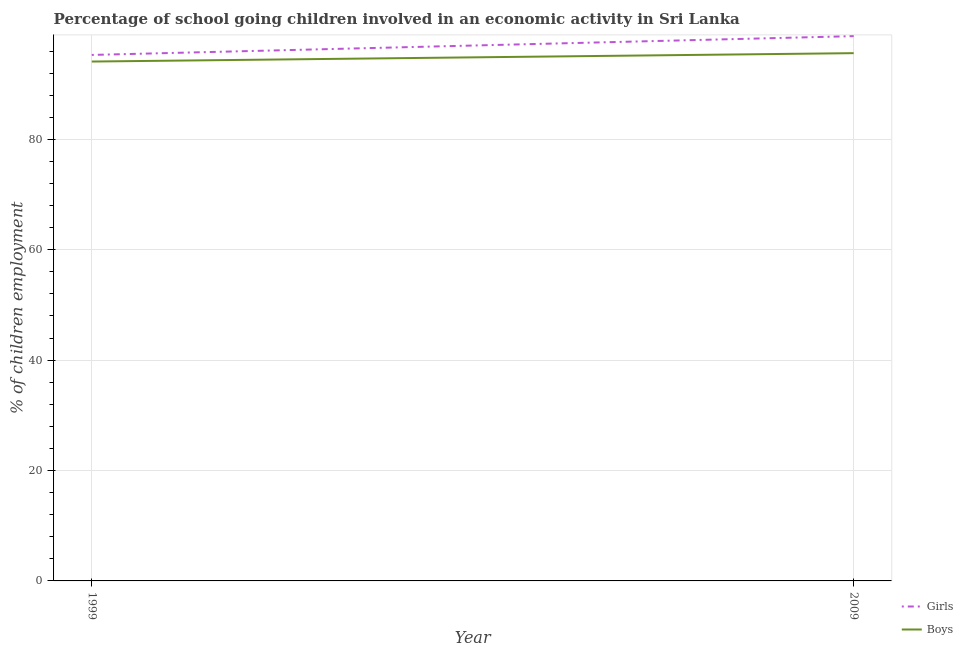Does the line corresponding to percentage of school going girls intersect with the line corresponding to percentage of school going boys?
Ensure brevity in your answer.  No. What is the percentage of school going girls in 1999?
Provide a short and direct response. 95.3. Across all years, what is the maximum percentage of school going boys?
Provide a succinct answer. 95.62. Across all years, what is the minimum percentage of school going boys?
Offer a very short reply. 94.1. In which year was the percentage of school going girls maximum?
Your answer should be very brief. 2009. In which year was the percentage of school going boys minimum?
Your answer should be very brief. 1999. What is the total percentage of school going boys in the graph?
Ensure brevity in your answer.  189.72. What is the difference between the percentage of school going girls in 1999 and that in 2009?
Give a very brief answer. -3.41. What is the difference between the percentage of school going boys in 2009 and the percentage of school going girls in 1999?
Your answer should be very brief. 0.32. What is the average percentage of school going girls per year?
Keep it short and to the point. 97. In the year 1999, what is the difference between the percentage of school going boys and percentage of school going girls?
Keep it short and to the point. -1.2. In how many years, is the percentage of school going boys greater than 52 %?
Your answer should be compact. 2. What is the ratio of the percentage of school going boys in 1999 to that in 2009?
Your response must be concise. 0.98. Does the percentage of school going girls monotonically increase over the years?
Your answer should be very brief. Yes. Is the percentage of school going boys strictly greater than the percentage of school going girls over the years?
Provide a succinct answer. No. How many lines are there?
Your response must be concise. 2. Are the values on the major ticks of Y-axis written in scientific E-notation?
Your answer should be very brief. No. Does the graph contain grids?
Your answer should be very brief. Yes. How are the legend labels stacked?
Offer a terse response. Vertical. What is the title of the graph?
Provide a succinct answer. Percentage of school going children involved in an economic activity in Sri Lanka. Does "Female" appear as one of the legend labels in the graph?
Offer a terse response. No. What is the label or title of the Y-axis?
Give a very brief answer. % of children employment. What is the % of children employment in Girls in 1999?
Your response must be concise. 95.3. What is the % of children employment in Boys in 1999?
Your response must be concise. 94.1. What is the % of children employment in Girls in 2009?
Ensure brevity in your answer.  98.71. What is the % of children employment of Boys in 2009?
Keep it short and to the point. 95.62. Across all years, what is the maximum % of children employment of Girls?
Offer a terse response. 98.71. Across all years, what is the maximum % of children employment of Boys?
Offer a very short reply. 95.62. Across all years, what is the minimum % of children employment of Girls?
Provide a short and direct response. 95.3. Across all years, what is the minimum % of children employment in Boys?
Offer a very short reply. 94.1. What is the total % of children employment of Girls in the graph?
Offer a terse response. 194. What is the total % of children employment of Boys in the graph?
Offer a very short reply. 189.72. What is the difference between the % of children employment of Girls in 1999 and that in 2009?
Offer a very short reply. -3.4. What is the difference between the % of children employment in Boys in 1999 and that in 2009?
Ensure brevity in your answer.  -1.52. What is the difference between the % of children employment of Girls in 1999 and the % of children employment of Boys in 2009?
Provide a succinct answer. -0.32. What is the average % of children employment of Girls per year?
Make the answer very short. 97. What is the average % of children employment in Boys per year?
Keep it short and to the point. 94.86. In the year 1999, what is the difference between the % of children employment in Girls and % of children employment in Boys?
Make the answer very short. 1.2. In the year 2009, what is the difference between the % of children employment in Girls and % of children employment in Boys?
Your answer should be compact. 3.08. What is the ratio of the % of children employment of Girls in 1999 to that in 2009?
Offer a very short reply. 0.97. What is the ratio of the % of children employment of Boys in 1999 to that in 2009?
Provide a short and direct response. 0.98. What is the difference between the highest and the second highest % of children employment in Girls?
Your answer should be very brief. 3.4. What is the difference between the highest and the second highest % of children employment of Boys?
Provide a succinct answer. 1.52. What is the difference between the highest and the lowest % of children employment in Girls?
Offer a very short reply. 3.4. What is the difference between the highest and the lowest % of children employment of Boys?
Provide a succinct answer. 1.52. 